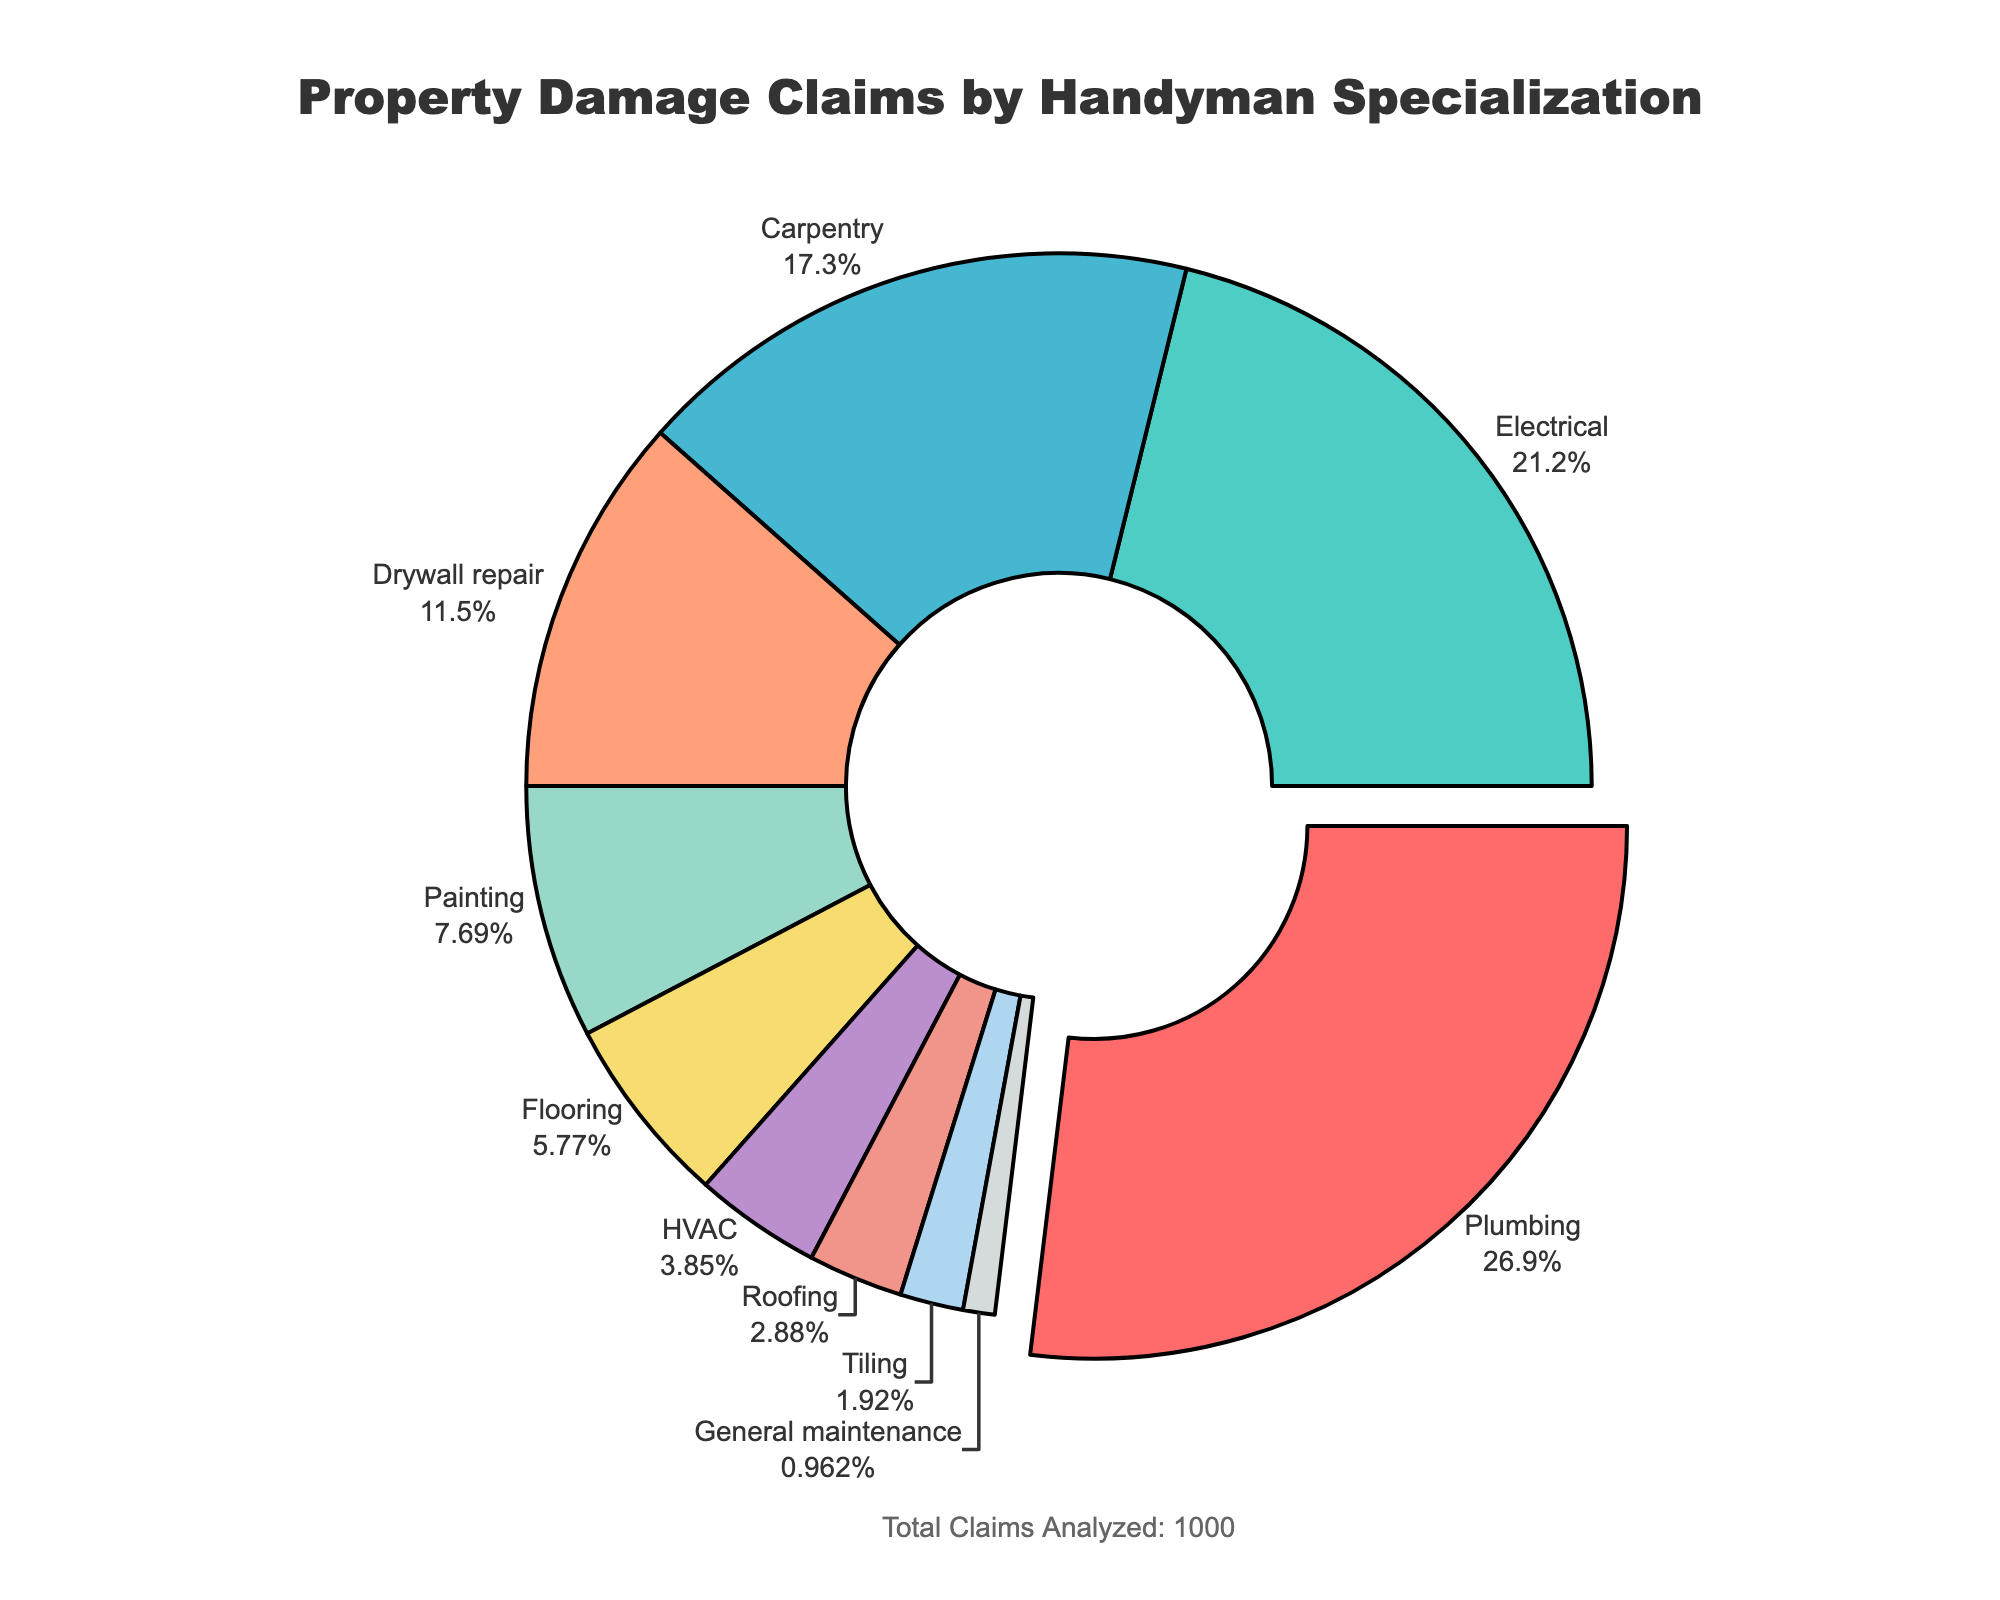What is the most common handyman specialization for property damage claims? The highlighted section of the chart is pulled out, showing that Plumbing has the largest proportion.
Answer: Plumbing Which specializations combined make up more than 50% of claimed damages? Adding the percentages of the largest specializations: Plumbing (28%) + Electrical (22%) together account for 50% of the claims.
Answer: Plumbing, Electrical How much more common are Plumbing claims compared to Roofing claims? The chart shows Plumbing at 28% and Roofing at 3%. The difference is 28% - 3% = 25%.
Answer: 25% What is the total percentage for the three least common specializations? Summing the percentages of the least common specializations: General maintenance (1%) + Tiling (2%) + Roofing (3%) is 1% + 2% + 3% = 6%.
Answer: 6% Which specialization has the second highest proportion of property damage claims? The chart shows the second largest portion is Electrical at 22%.
Answer: Electrical How does the proportion of Plumbing claims compare to the combined percentage of Painting and Flooring? Plumbing is 28%, and Painting plus Flooring is 8% + 6% = 14%. Plumbing is double this combination.
Answer: Twice as high What proportion of claims are for HVAC and Flooring combined? HVAC is at 4% and Flooring at 6%. Together, they make 4% + 6% = 10%.
Answer: 10% How does the brand color for the Carpentry section look visually? Carpentry is represented with a segment of color that appears blue in the pie chart.
Answer: Blue 